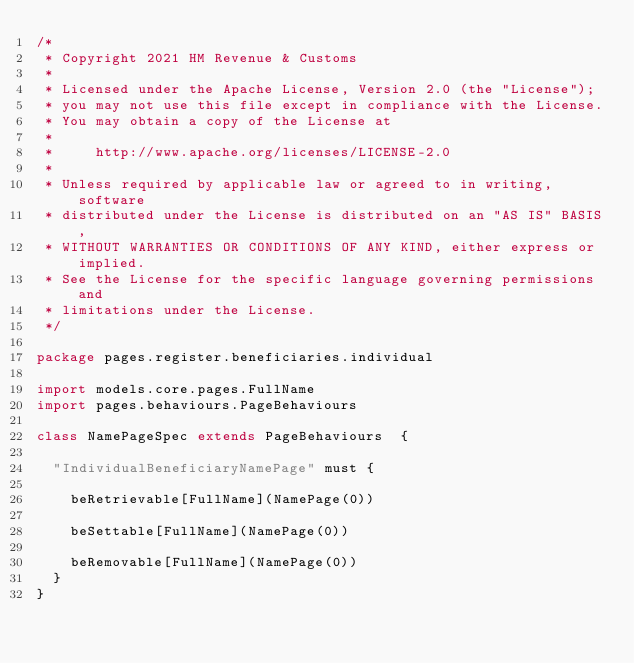<code> <loc_0><loc_0><loc_500><loc_500><_Scala_>/*
 * Copyright 2021 HM Revenue & Customs
 *
 * Licensed under the Apache License, Version 2.0 (the "License");
 * you may not use this file except in compliance with the License.
 * You may obtain a copy of the License at
 *
 *     http://www.apache.org/licenses/LICENSE-2.0
 *
 * Unless required by applicable law or agreed to in writing, software
 * distributed under the License is distributed on an "AS IS" BASIS,
 * WITHOUT WARRANTIES OR CONDITIONS OF ANY KIND, either express or implied.
 * See the License for the specific language governing permissions and
 * limitations under the License.
 */

package pages.register.beneficiaries.individual

import models.core.pages.FullName
import pages.behaviours.PageBehaviours

class NamePageSpec extends PageBehaviours  {

  "IndividualBeneficiaryNamePage" must {

    beRetrievable[FullName](NamePage(0))

    beSettable[FullName](NamePage(0))

    beRemovable[FullName](NamePage(0))
  }
}
</code> 